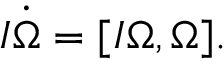Convert formula to latex. <formula><loc_0><loc_0><loc_500><loc_500>\begin{array} { r } { I \dot { \boldsymbol \Omega } = [ I { \boldsymbol \Omega } , { \boldsymbol \Omega } ] . } \end{array}</formula> 